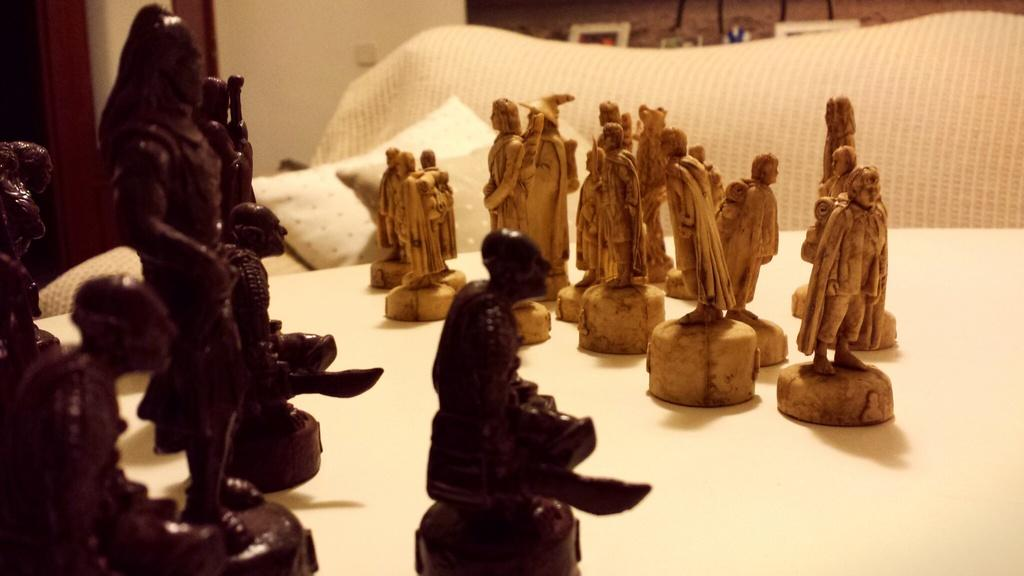What is the main subject of the image? There is a statue in the image. Where is the statue located? The statue is on a platform. What can be seen in the background of the image? There is a wall in the background of the image. Can you describe any other objects in the image? Yes, there is a pillow in the image. What type of net is being used to catch the bone in the image? There is no net or bone present in the image; it only features a statue on a platform and a wall in the background. 